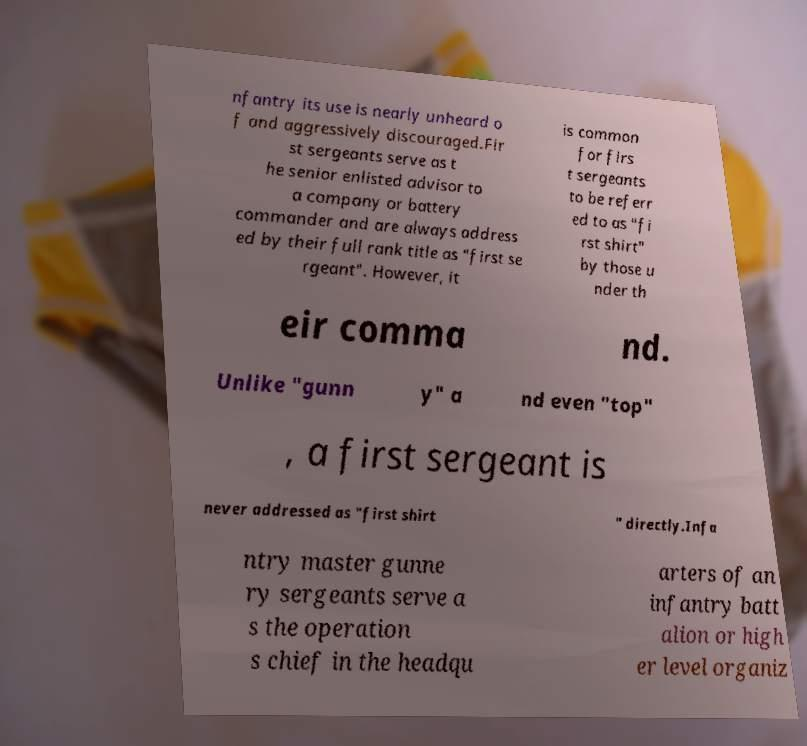Could you extract and type out the text from this image? nfantry its use is nearly unheard o f and aggressively discouraged.Fir st sergeants serve as t he senior enlisted advisor to a company or battery commander and are always address ed by their full rank title as "first se rgeant". However, it is common for firs t sergeants to be referr ed to as "fi rst shirt" by those u nder th eir comma nd. Unlike "gunn y" a nd even "top" , a first sergeant is never addressed as "first shirt " directly.Infa ntry master gunne ry sergeants serve a s the operation s chief in the headqu arters of an infantry batt alion or high er level organiz 